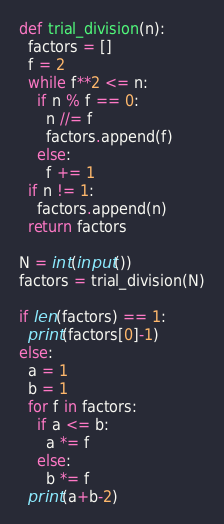Convert code to text. <code><loc_0><loc_0><loc_500><loc_500><_Python_>def trial_division(n):
  factors = []
  f = 2
  while f**2 <= n:
    if n % f == 0:
      n //= f
      factors.append(f)
    else:
      f += 1
  if n != 1:
    factors.append(n)
  return factors

N = int(input())
factors = trial_division(N)

if len(factors) == 1:
  print(factors[0]-1)
else:
  a = 1
  b = 1
  for f in factors:
    if a <= b:
      a *= f
    else:
      b *= f
  print(a+b-2)
</code> 